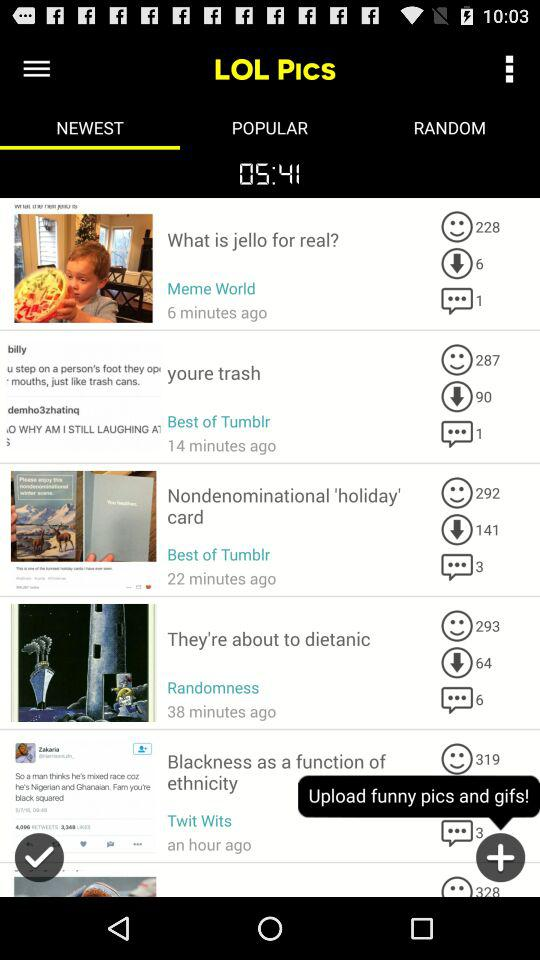What is the app name? The app name is "LOL PICS". 